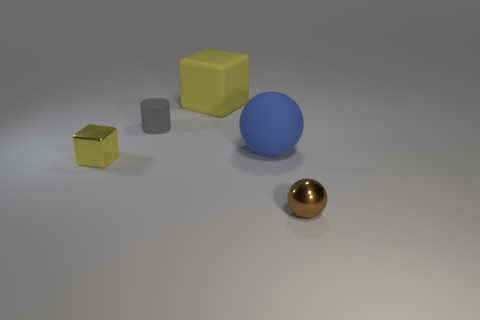Which object in the image looks the smoothest? The golden sphere appears to be the smoothest object in the image, with its polished and reflective surface indicating a lack of any noticeable texture. 